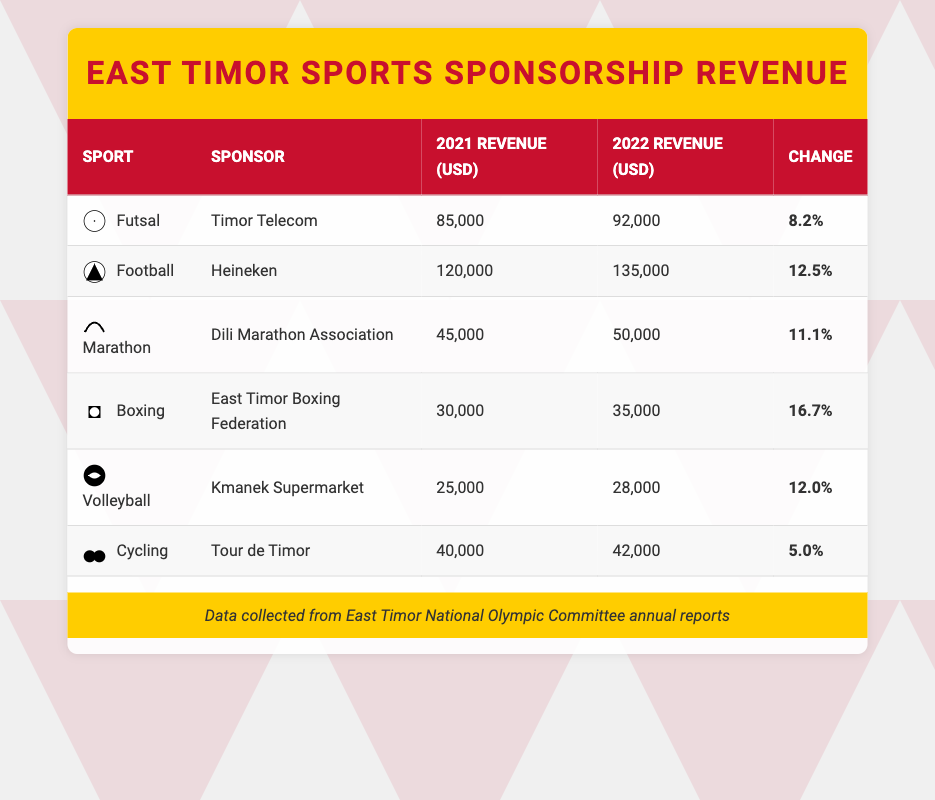What is the sponsorship revenue for Futsal in 2022? The table shows Futsal's sponsorship revenue for 2022 as 92,000 USD.
Answer: 92,000 USD Which sport had the highest revenue in 2021? By looking at the table, Football had the highest revenue in 2021 with 120,000 USD.
Answer: Football What percentage change in revenue did Futsal experience from 2021 to 2022? The table indicates Futsal had a percentage change of 8.2 percent from 2021 to 2022.
Answer: 8.2 percent Is the revenue for Boxing higher than that for Futsal in 2021? Comparing the revenues, Boxing had 30,000 USD while Futsal had 85,000 USD in 2021; therefore, the statement is false.
Answer: No What is the total revenue for all sports in 2022? To find the total revenue, we sum the 2022 revenues: 92,000 (Futsal) + 135,000 (Football) + 50,000 (Marathon) + 35,000 (Boxing) + 28,000 (Volleyball) + 42,000 (Cycling) = 382,000 USD.
Answer: 382,000 USD What sport saw the largest percentage increase in sponsorship revenue? By examining the percentage changes, Boxing with a 16.7 percent increase had the largest percentage increase in sponsorship revenue.
Answer: Boxing Was the revenue for Volleyball lower than that for Cycling in 2021? In 2021, Volleyball had 25,000 USD while Cycling had 40,000 USD, confirming that Volleyball's revenue was lower than Cycling's.
Answer: Yes What is the average revenue for all sports in 2021? We first calculate the total revenue for 2021: 85,000 (Futsal) + 120,000 (Football) + 45,000 (Marathon) + 30,000 (Boxing) + 25,000 (Volleyball) + 40,000 (Cycling) = 345,000 USD. Then we divide by the number of sports (6), yielding an average of 57,500 USD.
Answer: 57,500 USD How much more revenue did Football generate compared to Futsal in 2021? The difference in revenue between Football (120,000 USD) and Futsal (85,000 USD) is calculated as 120,000 - 85,000 = 35,000 USD.
Answer: 35,000 USD 